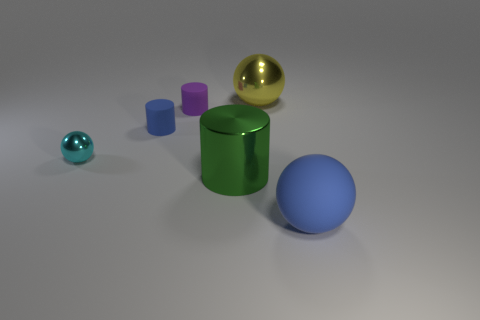There is a big object that is the same material as the yellow ball; what shape is it?
Ensure brevity in your answer.  Cylinder. There is a shiny ball that is in front of the blue matte thing behind the green metallic cylinder; what color is it?
Your answer should be compact. Cyan. Is the color of the small shiny sphere the same as the large cylinder?
Your answer should be very brief. No. What material is the small object behind the blue rubber thing on the left side of the big rubber sphere?
Make the answer very short. Rubber. There is another big yellow thing that is the same shape as the large matte object; what is its material?
Offer a terse response. Metal. There is a big sphere that is on the left side of the blue matte object in front of the small cyan metallic object; is there a large yellow metal sphere in front of it?
Provide a short and direct response. No. What number of other things are the same color as the tiny ball?
Offer a terse response. 0. How many objects are to the left of the small blue object and behind the tiny cyan ball?
Your answer should be compact. 0. What shape is the yellow shiny thing?
Your answer should be very brief. Sphere. What number of other things are there of the same material as the small purple cylinder
Ensure brevity in your answer.  2. 